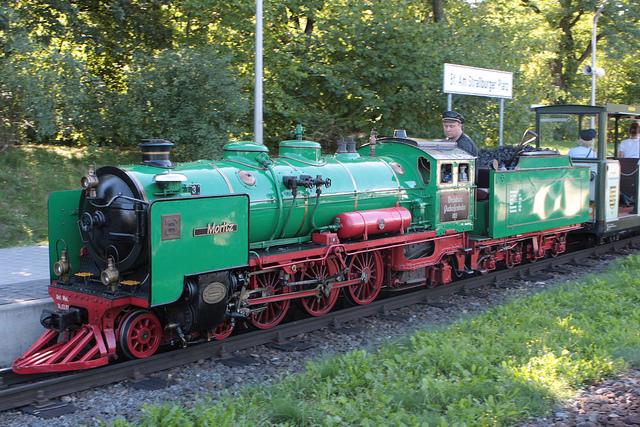Is this a model train?
Quick response, please. No. Is the a steam engine?
Answer briefly. Yes. Are there people on the train?
Short answer required. Yes. 